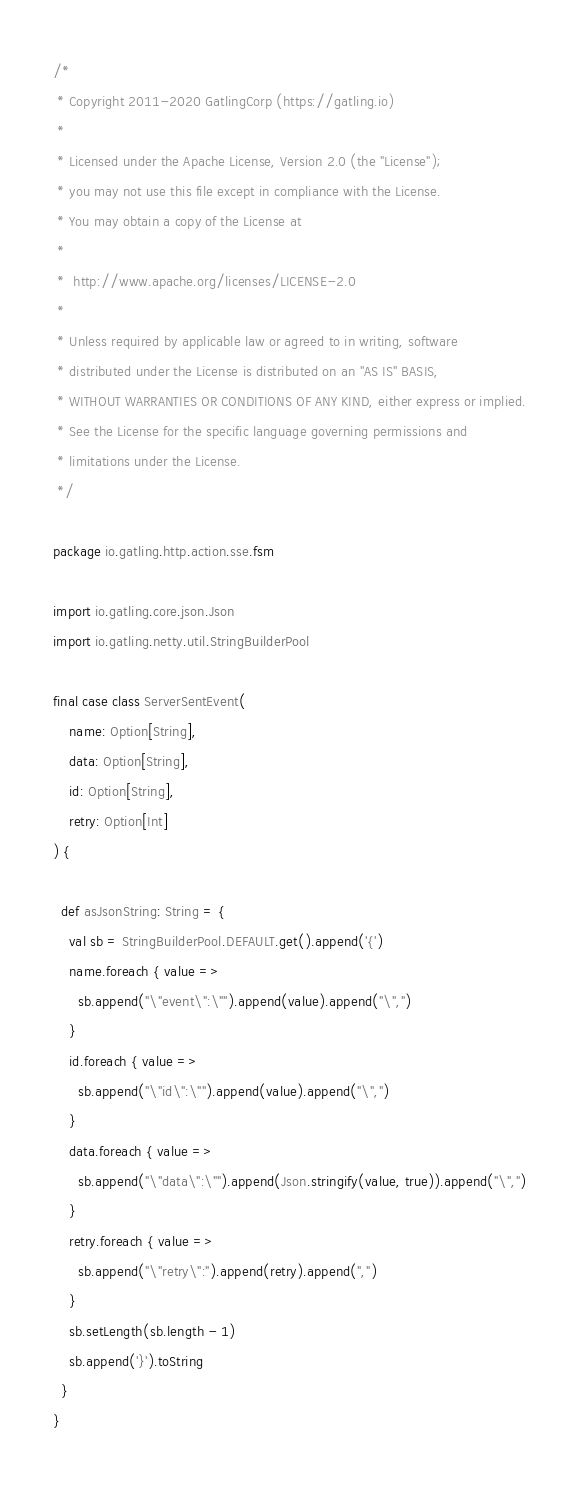<code> <loc_0><loc_0><loc_500><loc_500><_Scala_>/*
 * Copyright 2011-2020 GatlingCorp (https://gatling.io)
 *
 * Licensed under the Apache License, Version 2.0 (the "License");
 * you may not use this file except in compliance with the License.
 * You may obtain a copy of the License at
 *
 *  http://www.apache.org/licenses/LICENSE-2.0
 *
 * Unless required by applicable law or agreed to in writing, software
 * distributed under the License is distributed on an "AS IS" BASIS,
 * WITHOUT WARRANTIES OR CONDITIONS OF ANY KIND, either express or implied.
 * See the License for the specific language governing permissions and
 * limitations under the License.
 */

package io.gatling.http.action.sse.fsm

import io.gatling.core.json.Json
import io.gatling.netty.util.StringBuilderPool

final case class ServerSentEvent(
    name: Option[String],
    data: Option[String],
    id: Option[String],
    retry: Option[Int]
) {

  def asJsonString: String = {
    val sb = StringBuilderPool.DEFAULT.get().append('{')
    name.foreach { value =>
      sb.append("\"event\":\"").append(value).append("\",")
    }
    id.foreach { value =>
      sb.append("\"id\":\"").append(value).append("\",")
    }
    data.foreach { value =>
      sb.append("\"data\":\"").append(Json.stringify(value, true)).append("\",")
    }
    retry.foreach { value =>
      sb.append("\"retry\":").append(retry).append(",")
    }
    sb.setLength(sb.length - 1)
    sb.append('}').toString
  }
}
</code> 